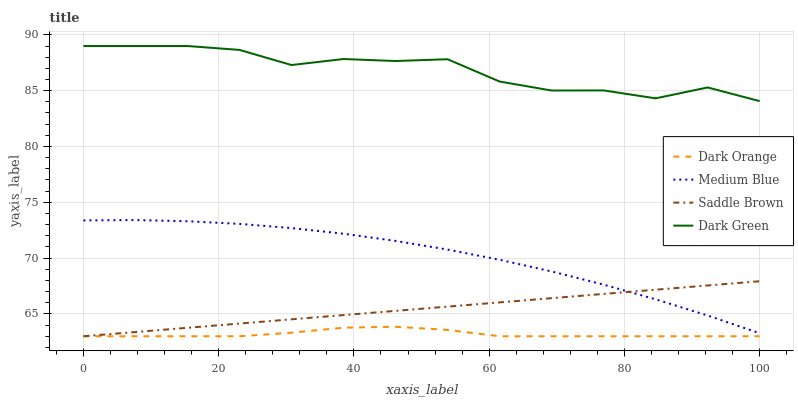Does Dark Orange have the minimum area under the curve?
Answer yes or no. Yes. Does Dark Green have the maximum area under the curve?
Answer yes or no. Yes. Does Medium Blue have the minimum area under the curve?
Answer yes or no. No. Does Medium Blue have the maximum area under the curve?
Answer yes or no. No. Is Saddle Brown the smoothest?
Answer yes or no. Yes. Is Dark Green the roughest?
Answer yes or no. Yes. Is Medium Blue the smoothest?
Answer yes or no. No. Is Medium Blue the roughest?
Answer yes or no. No. Does Dark Orange have the lowest value?
Answer yes or no. Yes. Does Medium Blue have the lowest value?
Answer yes or no. No. Does Dark Green have the highest value?
Answer yes or no. Yes. Does Medium Blue have the highest value?
Answer yes or no. No. Is Dark Orange less than Dark Green?
Answer yes or no. Yes. Is Dark Green greater than Dark Orange?
Answer yes or no. Yes. Does Saddle Brown intersect Medium Blue?
Answer yes or no. Yes. Is Saddle Brown less than Medium Blue?
Answer yes or no. No. Is Saddle Brown greater than Medium Blue?
Answer yes or no. No. Does Dark Orange intersect Dark Green?
Answer yes or no. No. 